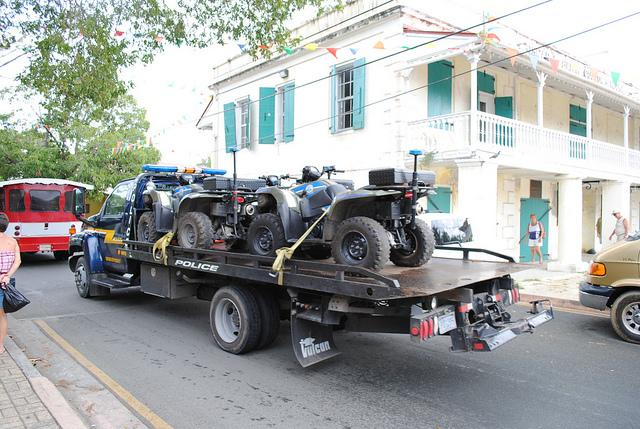The ATVs being carried on the flatbed truck are used by which public agency? police 